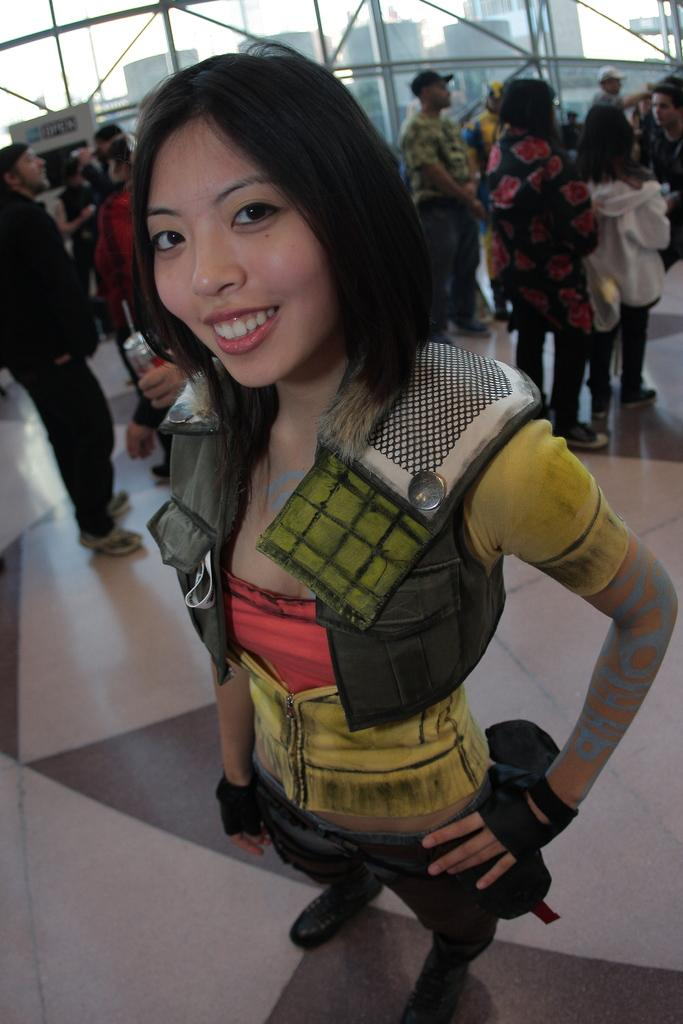What is the expression of the person in the image? The person in the image has a smile. What is the person doing in the image? The person is standing on a surface. Can you describe the background of the image? There are a few people in the background of the image. What type of wall can be seen in the image? There is a glass wall in the image. What material is used for some objects in the image? There are metal objects in the image. What type of slave is depicted in the image? There is no slave depicted in the image; it features a person with a smile standing on a surface. What type of writer is shown in the image? There is no writer depicted in the image; it features a person with a smile standing on a surface. 